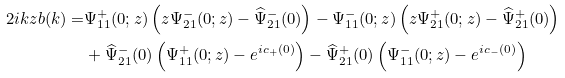Convert formula to latex. <formula><loc_0><loc_0><loc_500><loc_500>2 i k z b ( k ) = & \Psi ^ { + } _ { 1 1 } ( 0 ; z ) \left ( z \Psi ^ { - } _ { 2 1 } ( 0 ; z ) - \widehat { \Psi } ^ { - } _ { 2 1 } ( 0 ) \right ) - \Psi ^ { - } _ { 1 1 } ( 0 ; z ) \left ( z \Psi ^ { + } _ { 2 1 } ( 0 ; z ) - \widehat { \Psi } ^ { + } _ { 2 1 } ( 0 ) \right ) \\ & + \widehat { \Psi } ^ { - } _ { 2 1 } ( 0 ) \left ( \Psi ^ { + } _ { 1 1 } ( 0 ; z ) - e ^ { i c _ { + } ( 0 ) } \right ) - \widehat { \Psi } ^ { + } _ { 2 1 } ( 0 ) \left ( \Psi ^ { - } _ { 1 1 } ( 0 ; z ) - e ^ { i c _ { - } ( 0 ) } \right )</formula> 